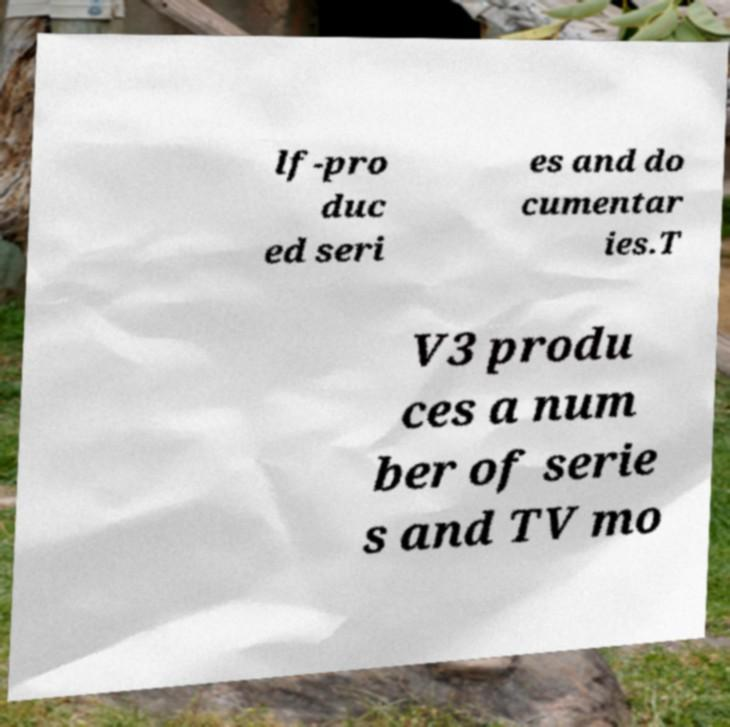Please identify and transcribe the text found in this image. lf-pro duc ed seri es and do cumentar ies.T V3 produ ces a num ber of serie s and TV mo 